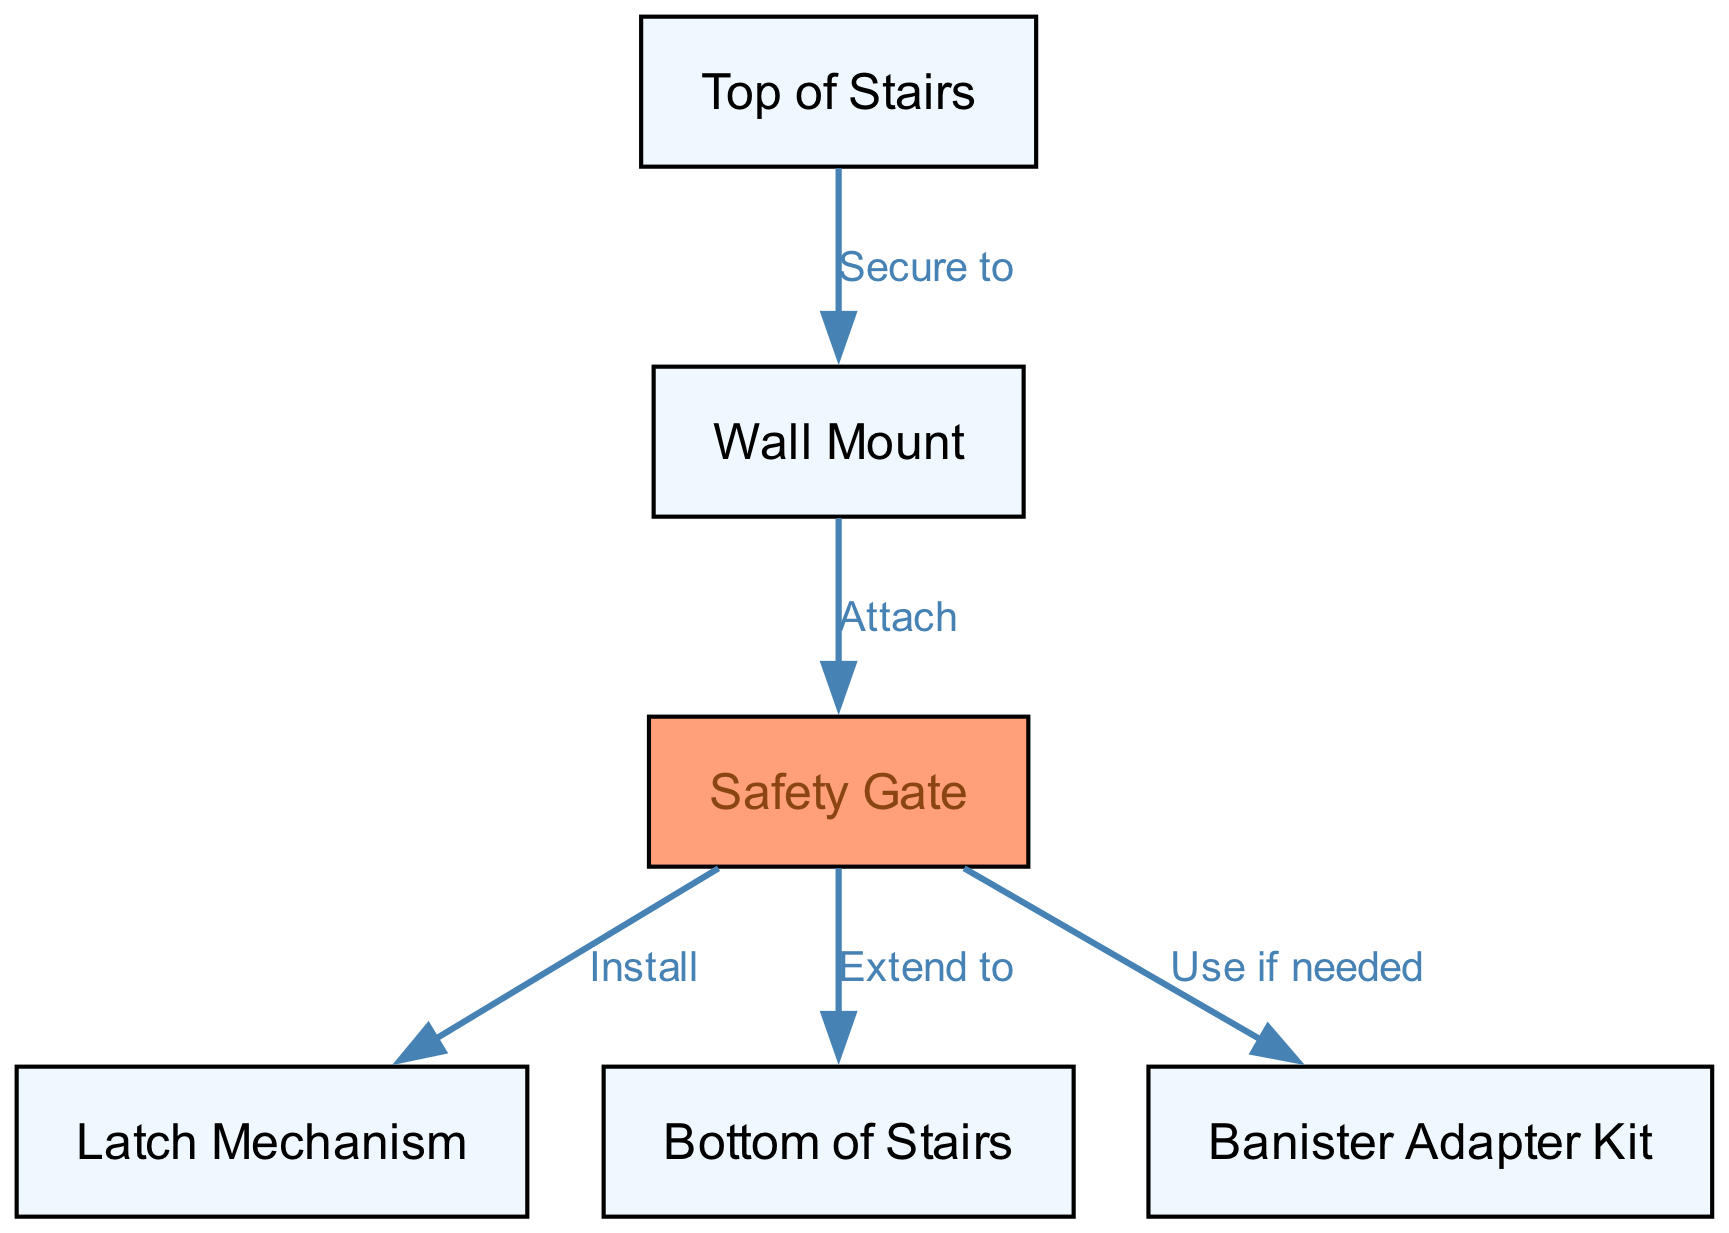What is the total number of nodes in the diagram? The diagram includes six identifiable nodes: "Top of Stairs," "Wall Mount," "Safety Gate," "Latch Mechanism," "Bottom of Stairs," and "Banister Adapter Kit." Thus, by counting them, we determine there are six nodes in total.
Answer: 6 What is the label of the node with ID "3"? The node with ID "3" is labeled as "Safety Gate." This can be directly confirmed by referring to the node data in the diagram's structure.
Answer: Safety Gate Which node is secured to the "Top of Stairs"? The "Wall Mount" is the node that is secured to the "Top of Stairs," as indicated by the edge connection labeled "Secure to," which points from node ID "1" to node ID "2."
Answer: Wall Mount What label follows the "Safety Gate" node in the installation process? After the "Safety Gate," the next node in the process is "Latch Mechanism," as there is a direct edge from node ID "3" (Safety Gate) to node ID "4" (Latch Mechanism) with the label "Install."
Answer: Latch Mechanism If the "Safety Gate" is extended, which node does it connect to? When the "Safety Gate" is extended, it connects to the "Bottom of Stairs." This is shown by the edge from node ID "3" to node ID "5," labeled "Extend to."
Answer: Bottom of Stairs Which node represents a conditional component in the installation? The "Banister Adapter Kit" represents a conditional component, as it is indicated with the phrase "Use if needed" connecting from the "Safety Gate." This implies it is not always required.
Answer: Banister Adapter Kit What is the relationship between "Wall Mount" and "Safety Gate"? The relationship is defined as "Attach," which indicates that the "Wall Mount" is the component that helps secure the "Safety Gate" in place. This connection is directly evident in the edges of the diagram.
Answer: Attach What type of diagram is being represented here? The diagram is an installation schematic, specifically intended for visualizing how to install a baby safety gate in a nursery environment, facilitating an understanding of the components and their relationships.
Answer: Installation schematic 